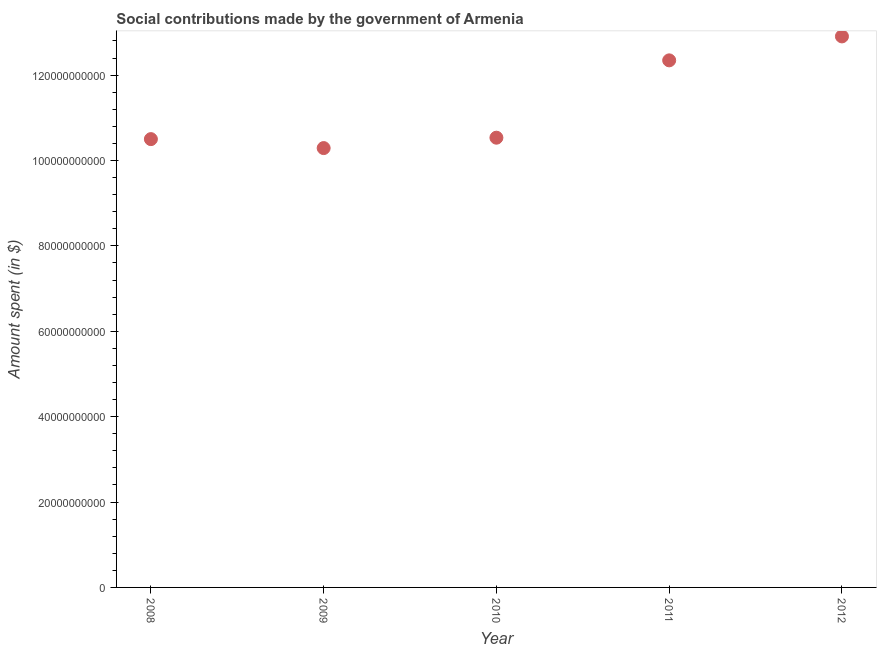What is the amount spent in making social contributions in 2011?
Ensure brevity in your answer.  1.23e+11. Across all years, what is the maximum amount spent in making social contributions?
Give a very brief answer. 1.29e+11. Across all years, what is the minimum amount spent in making social contributions?
Ensure brevity in your answer.  1.03e+11. In which year was the amount spent in making social contributions maximum?
Ensure brevity in your answer.  2012. What is the sum of the amount spent in making social contributions?
Provide a short and direct response. 5.66e+11. What is the difference between the amount spent in making social contributions in 2009 and 2012?
Your response must be concise. -2.62e+1. What is the average amount spent in making social contributions per year?
Your answer should be very brief. 1.13e+11. What is the median amount spent in making social contributions?
Provide a succinct answer. 1.05e+11. What is the ratio of the amount spent in making social contributions in 2009 to that in 2010?
Offer a terse response. 0.98. Is the amount spent in making social contributions in 2010 less than that in 2011?
Provide a short and direct response. Yes. What is the difference between the highest and the second highest amount spent in making social contributions?
Offer a very short reply. 5.61e+09. Is the sum of the amount spent in making social contributions in 2008 and 2012 greater than the maximum amount spent in making social contributions across all years?
Make the answer very short. Yes. What is the difference between the highest and the lowest amount spent in making social contributions?
Your answer should be very brief. 2.62e+1. In how many years, is the amount spent in making social contributions greater than the average amount spent in making social contributions taken over all years?
Offer a terse response. 2. How many dotlines are there?
Offer a terse response. 1. Are the values on the major ticks of Y-axis written in scientific E-notation?
Your answer should be very brief. No. Does the graph contain grids?
Provide a succinct answer. No. What is the title of the graph?
Ensure brevity in your answer.  Social contributions made by the government of Armenia. What is the label or title of the X-axis?
Ensure brevity in your answer.  Year. What is the label or title of the Y-axis?
Your answer should be very brief. Amount spent (in $). What is the Amount spent (in $) in 2008?
Offer a very short reply. 1.05e+11. What is the Amount spent (in $) in 2009?
Your answer should be very brief. 1.03e+11. What is the Amount spent (in $) in 2010?
Your response must be concise. 1.05e+11. What is the Amount spent (in $) in 2011?
Your answer should be very brief. 1.23e+11. What is the Amount spent (in $) in 2012?
Offer a terse response. 1.29e+11. What is the difference between the Amount spent (in $) in 2008 and 2009?
Keep it short and to the point. 2.10e+09. What is the difference between the Amount spent (in $) in 2008 and 2010?
Keep it short and to the point. -3.35e+08. What is the difference between the Amount spent (in $) in 2008 and 2011?
Give a very brief answer. -1.84e+1. What is the difference between the Amount spent (in $) in 2008 and 2012?
Your answer should be compact. -2.41e+1. What is the difference between the Amount spent (in $) in 2009 and 2010?
Provide a succinct answer. -2.43e+09. What is the difference between the Amount spent (in $) in 2009 and 2011?
Make the answer very short. -2.05e+1. What is the difference between the Amount spent (in $) in 2009 and 2012?
Provide a succinct answer. -2.62e+1. What is the difference between the Amount spent (in $) in 2010 and 2011?
Keep it short and to the point. -1.81e+1. What is the difference between the Amount spent (in $) in 2010 and 2012?
Make the answer very short. -2.37e+1. What is the difference between the Amount spent (in $) in 2011 and 2012?
Keep it short and to the point. -5.61e+09. What is the ratio of the Amount spent (in $) in 2008 to that in 2010?
Offer a very short reply. 1. What is the ratio of the Amount spent (in $) in 2008 to that in 2011?
Give a very brief answer. 0.85. What is the ratio of the Amount spent (in $) in 2008 to that in 2012?
Provide a short and direct response. 0.81. What is the ratio of the Amount spent (in $) in 2009 to that in 2011?
Your answer should be very brief. 0.83. What is the ratio of the Amount spent (in $) in 2009 to that in 2012?
Your answer should be compact. 0.8. What is the ratio of the Amount spent (in $) in 2010 to that in 2011?
Your response must be concise. 0.85. What is the ratio of the Amount spent (in $) in 2010 to that in 2012?
Keep it short and to the point. 0.82. 